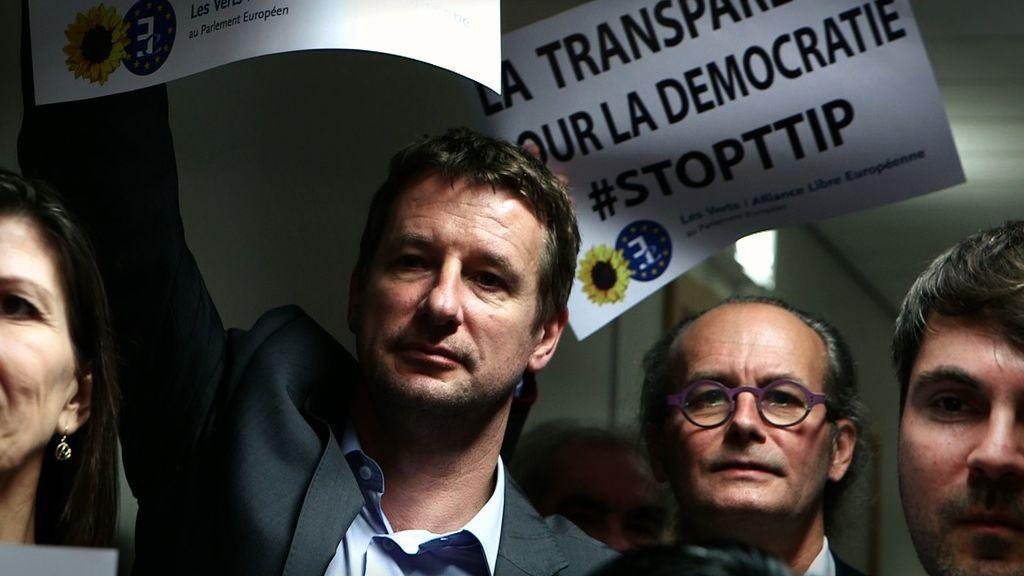How many people are present in the image? There are people in the image, but the exact number is not specified. What are two of the people doing in the image? Two people are holding posters in the image. Can you describe any specific feature of one of the people? One person is wearing glasses (specs) in the image. What can be seen in the background of the image? There is a wall in the background of the image. What type of canvas is being used to paint the night scene in the image? There is no canvas or night scene present in the image; it features people holding posters and a wall in the background. 